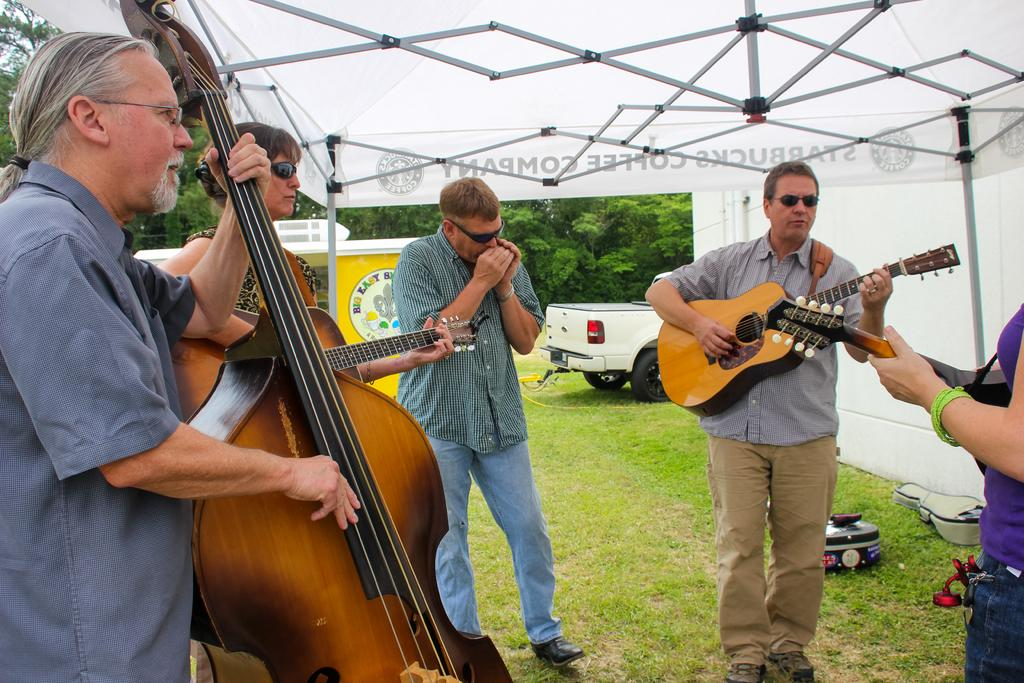What type of area is shown in the image? The image depicts an open area. What are the people in the image doing? The people are playing music using a guitar and other instruments. What is the surface the people are standing on? The people are standing on grass. What can be seen in the background of the image? There is a vehicle and trees visible in the background. What type of destruction is being caused by the people in the image? There is no destruction being caused by the people in the image; they are playing music. What type of joke is being told by the people in the image? There is no joke being told by the people in the image; they are playing music. 